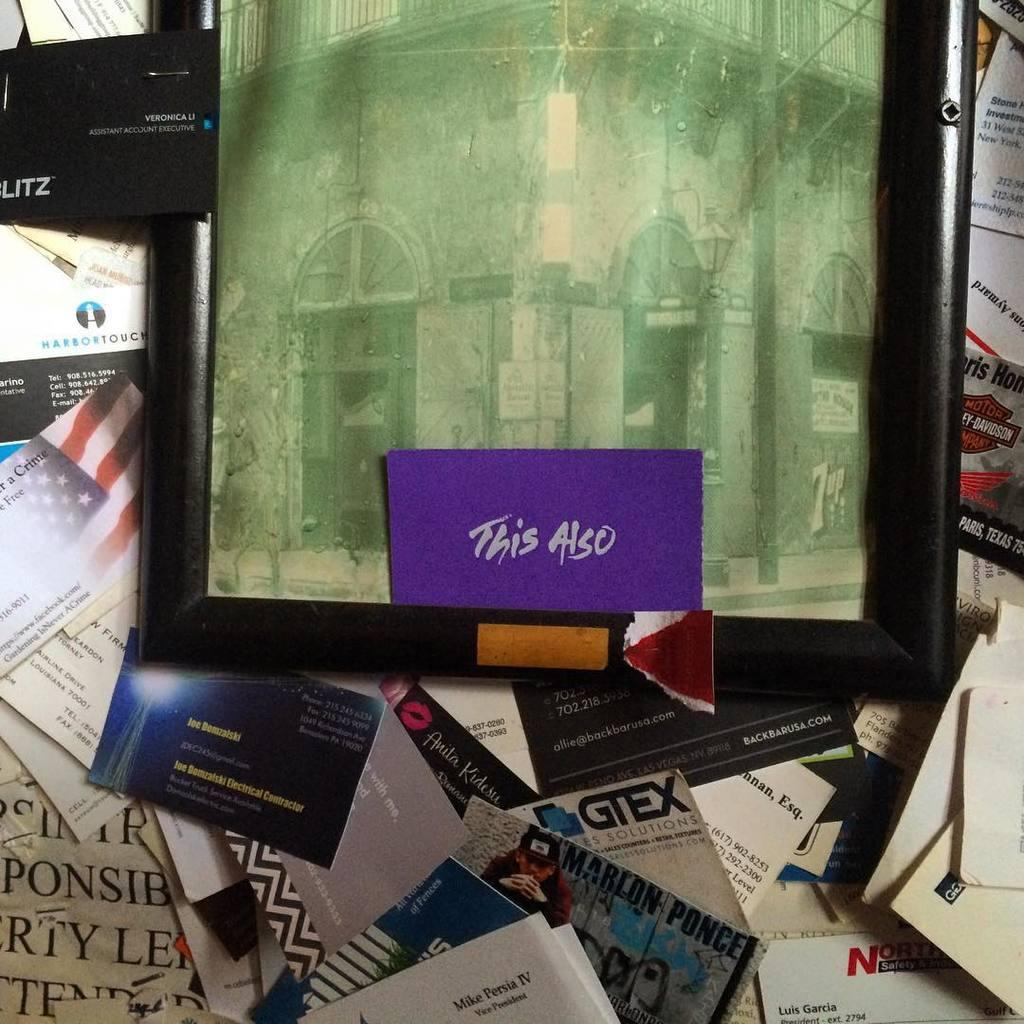Provide a one-sentence caption for the provided image. Black picture frame with antique greened picture of a corner as the words This Also is printed on bottom of picture on purple card. 